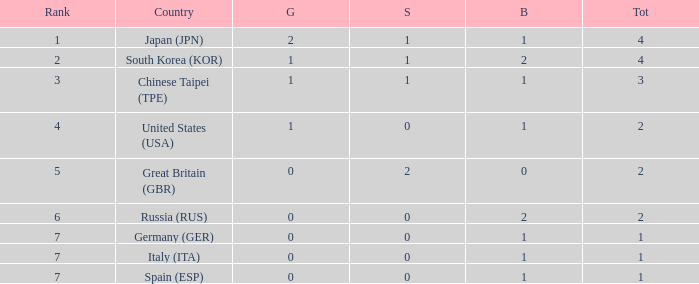What is the rank of the country with more than 2 medals, and 2 gold medals? 1.0. 